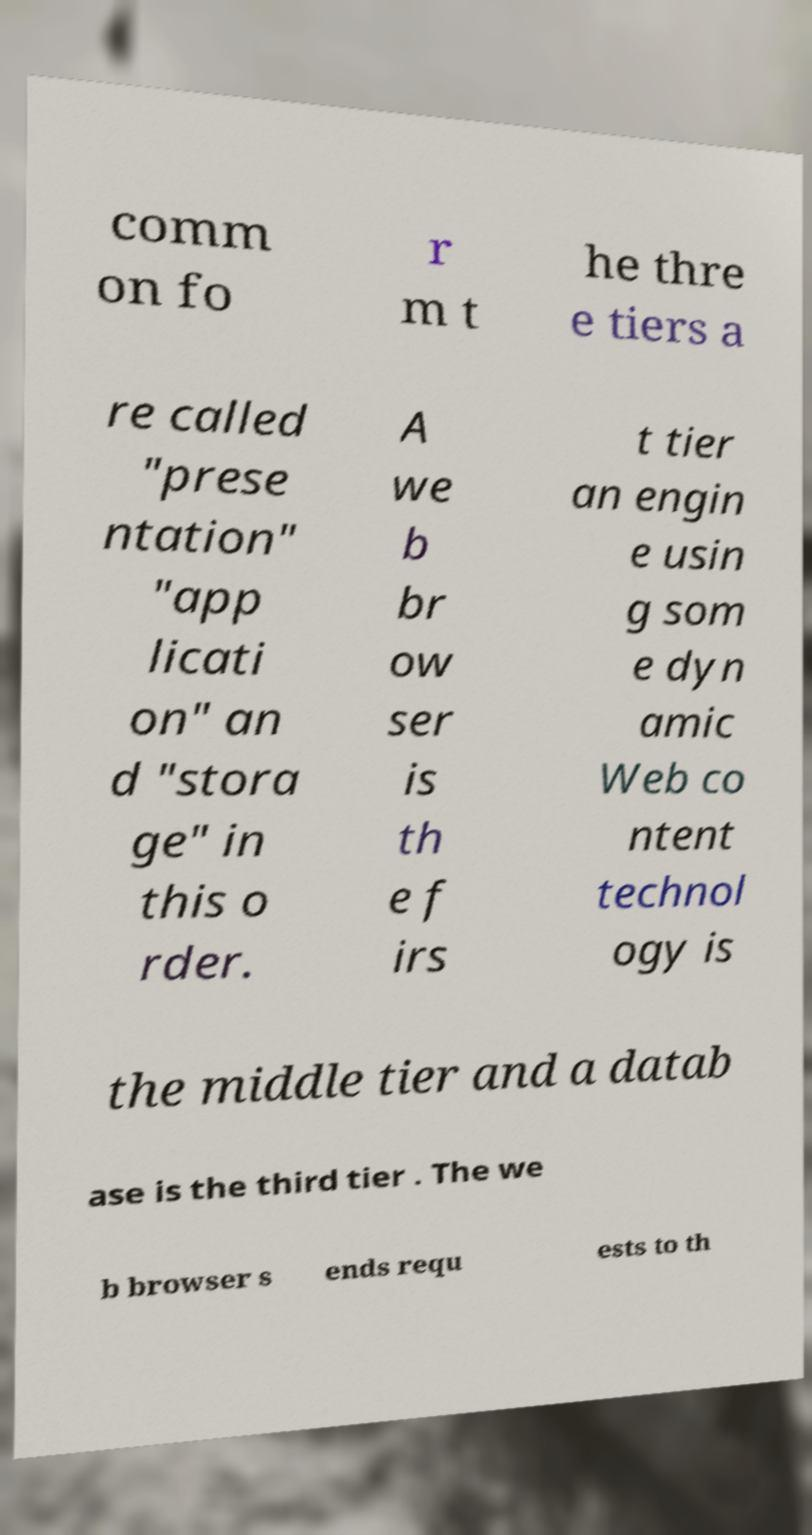Could you extract and type out the text from this image? comm on fo r m t he thre e tiers a re called "prese ntation" "app licati on" an d "stora ge" in this o rder. A we b br ow ser is th e f irs t tier an engin e usin g som e dyn amic Web co ntent technol ogy is the middle tier and a datab ase is the third tier . The we b browser s ends requ ests to th 